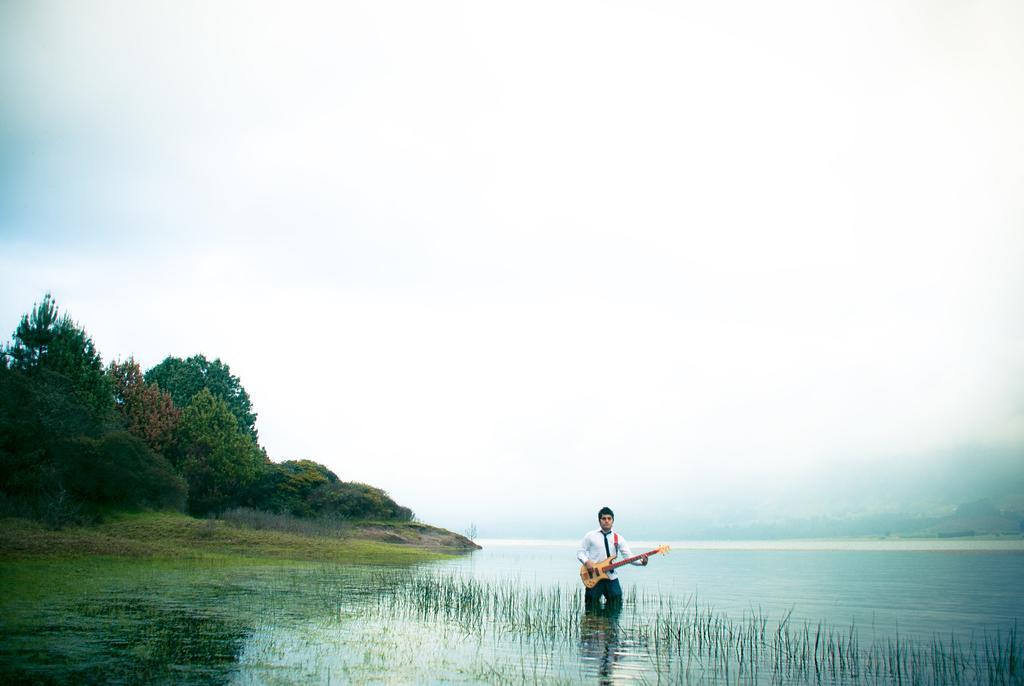Describe this image in one or two sentences. In this picture, there is a sea at the bottom. In the sea, there is a man wearing a white shirt and holding a guitar. Towards the left, there are trees and grass. On the top, there is a sky. 